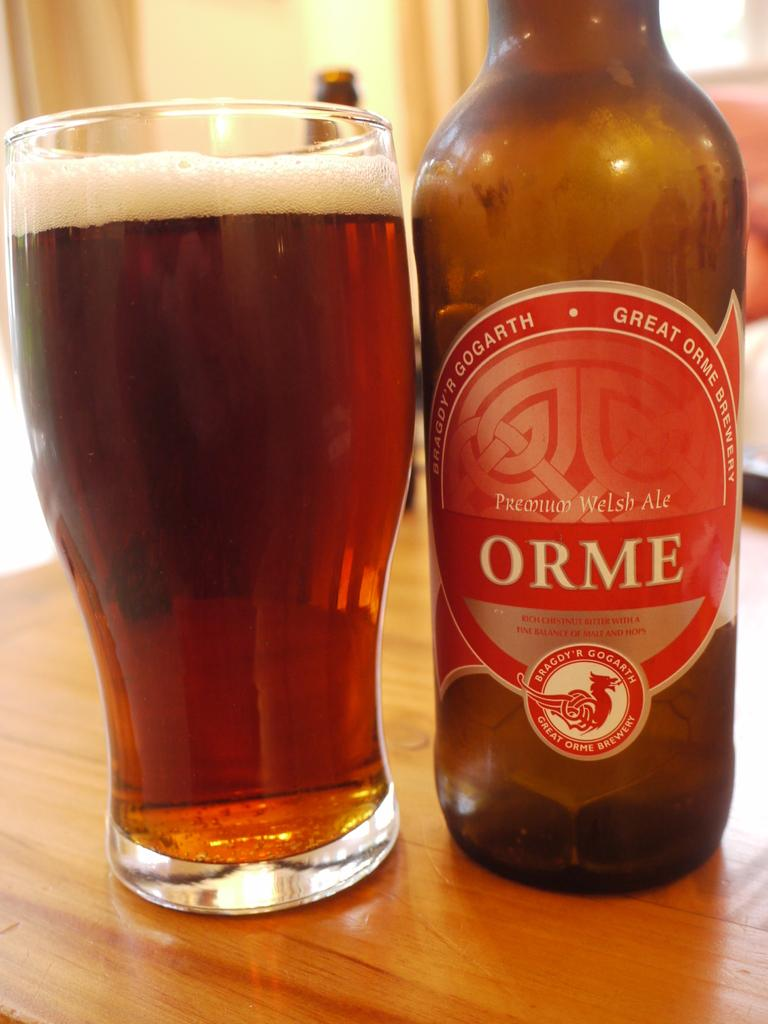<image>
Offer a succinct explanation of the picture presented. A bottle of Premium Welsh Ale next to a glass full of beer. 